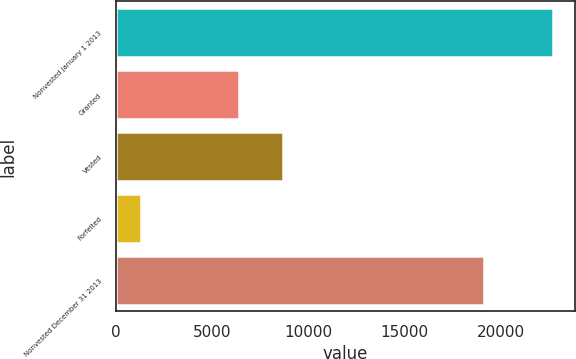Convert chart to OTSL. <chart><loc_0><loc_0><loc_500><loc_500><bar_chart><fcel>Nonvested January 1 2013<fcel>Granted<fcel>Vested<fcel>Forfeited<fcel>Nonvested December 31 2013<nl><fcel>22743<fcel>6394<fcel>8705<fcel>1298<fcel>19134<nl></chart> 